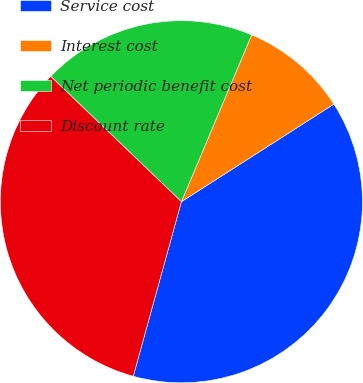Convert chart to OTSL. <chart><loc_0><loc_0><loc_500><loc_500><pie_chart><fcel>Service cost<fcel>Interest cost<fcel>Net periodic benefit cost<fcel>Discount rate<nl><fcel>38.35%<fcel>9.59%<fcel>19.18%<fcel>32.89%<nl></chart> 